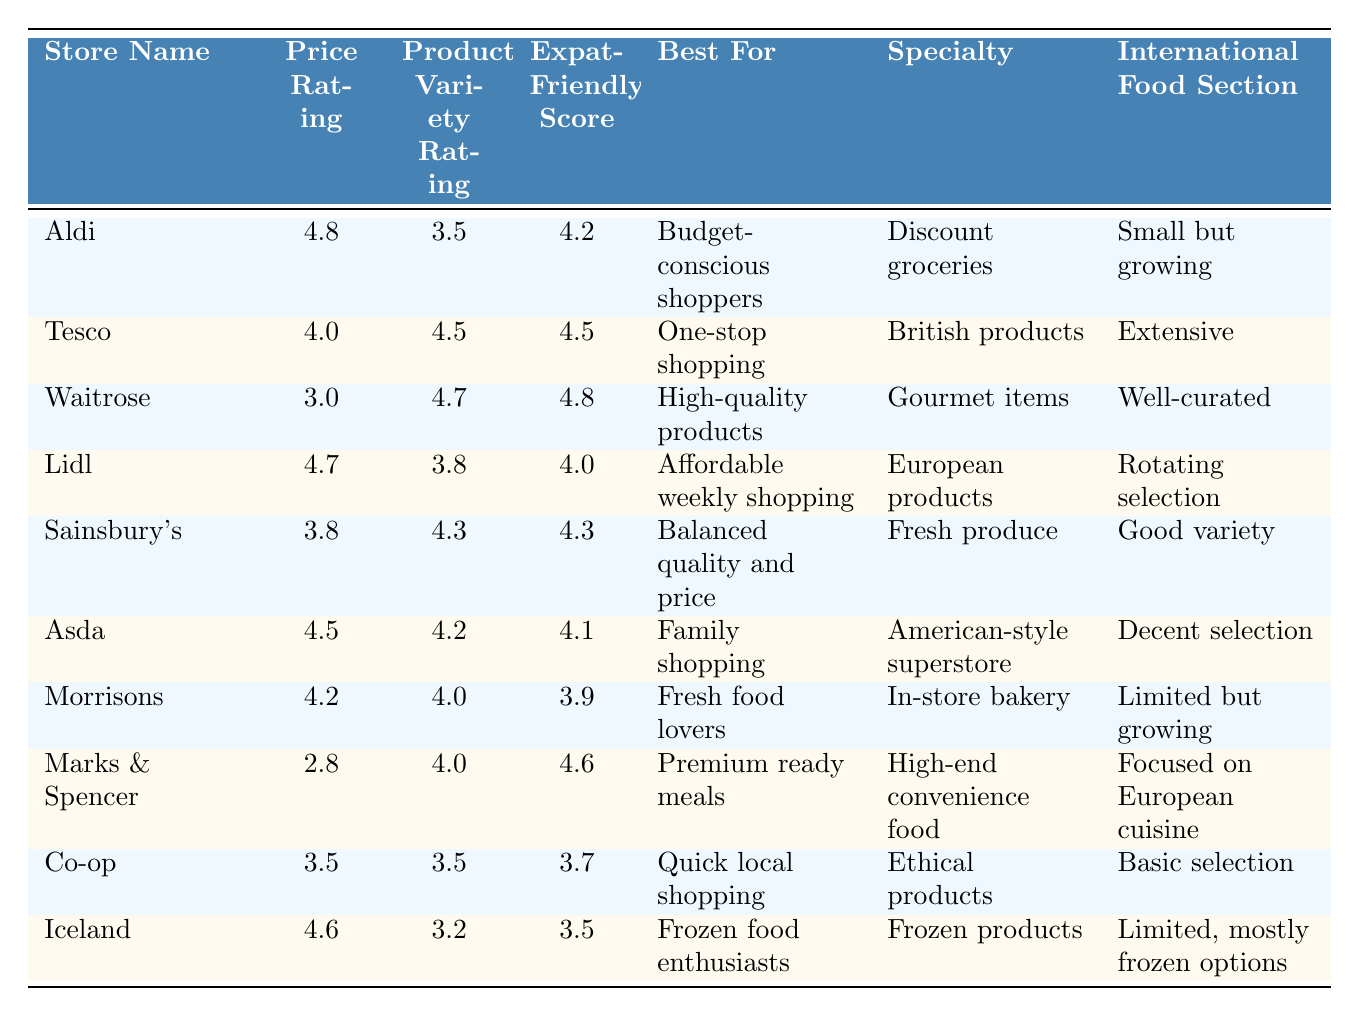What is the highest Price Rating among the grocery stores? The highest Price Rating in the table is found by looking for the maximum value in the Price Rating column. Aldi has a Price Rating of 4.8, which is the highest.
Answer: 4.8 Which store has the best Expat-Friendly Score? To determine this, we check the Expat-Friendly Score for all stores listed in the table. Waitrose has the highest score of 4.8.
Answer: Waitrose What is the average Product Variety Rating for the stores? We sum the Product Variety Ratings of all stores (3.5 + 4.5 + 4.7 + 3.8 + 4.3 + 4.2 + 4.0 + 4.0 + 3.5 + 3.2 = 43.7) and divide by the number of stores (10) to find the average, which is 43.7 / 10 = 4.37.
Answer: 4.37 Is there a store that combines low Price Rating with high Product Variety Rating? We check for stores where the Price Rating is below 3.5 and the Product Variety Rating is above 4.0. The only store fitting this condition is Waitrose with a low Price Rating of 3.0 and Product Variety Rating of 4.7.
Answer: Yes Which store is the best for frozen food enthusiasts based on the table? We look for a store that is specifically noted for frozen foods. Iceland is highlighted as being best for frozen food enthusiasts.
Answer: Iceland How many stores have a Product Variety Rating of 4.0 or higher? We count the stores with a Product Variety Rating at least 4.0, which are Tesco, Waitrose, Sainsbury's, Asda, Morrisons, Marks & Spencer. There are a total of 6 stores.
Answer: 6 Which store has the lowest Price Rating and what is it? We find the store with the minimum Price Rating by examining each store's Price Rating. Marks & Spencer has the lowest Price Rating at 2.8.
Answer: Marks & Spencer, 2.8 If we consider the specialty of discount groceries, which store would it be? We look for the store with a specialty specifically noted as discount groceries, which is Aldi.
Answer: Aldi Which store offers the most extensive selection of international foods? We can evaluate which store has the best description of their international food section. Tesco has an "Extensive" international food section, which is the highest among the listed stores.
Answer: Tesco Which store is rated best for "High-quality products" according to the table? We search for the store that specifies 'High-quality products' in the "Best For" column. This is clearly Waitrose.
Answer: Waitrose 